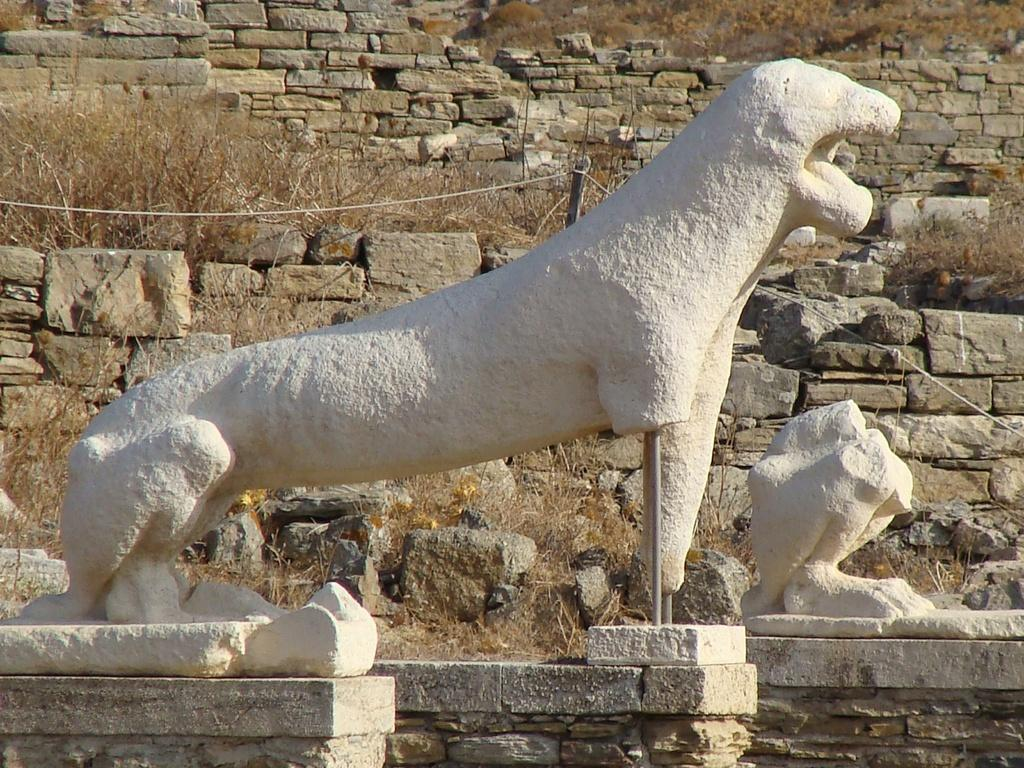What is the color of the objects in the image? The objects in the image are white-colored. What type of vegetation can be seen in the image? There is grass in the image. What kind of material is present in the image? There is a wire in the image. What other objects can be found in the image? There are stones in the image. What type of mitten is the father using to rake the leaves in the image? There is no mitten, father, or rake present in the image. 